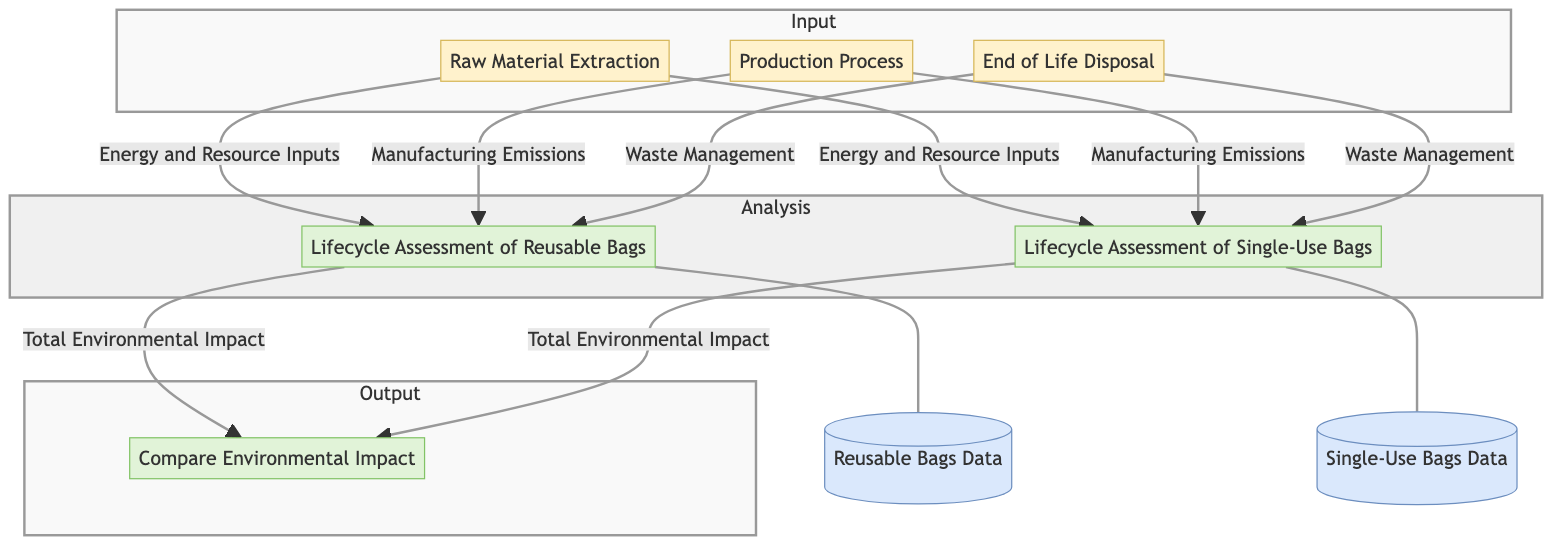What is one input entity for the reusable bags lifecycle assessment? The input entities for the lifecycle assessment of reusable bags include "Raw Material Extraction," "Production Process," and "End of Life Disposal." "Raw Material Extraction" is one of those input entities.
Answer: Raw Material Extraction How many processes are shown in the diagram? The diagram includes three distinct processes: "Lifecycle Assessment of Reusable Bags," "Lifecycle Assessment of Single-Use Bags," and "Compare Environmental Impact." Thus, the total number is three.
Answer: 3 What type of emissions are associated with the production process for both bag types? The production process contributes manufacturing emissions to the lifecycle assessments of both reusable and single-use bags, as indicated by the data flows connecting "Production Process" to each lifecycle assessment.
Answer: Manufacturing Emissions Which data store is linked to the lifecycle assessment of reusable bags? The "Reusable Bags Data" store is connected to the "Lifecycle Assessment of Reusable Bags" process, as shown by the dashed line that connects them in the diagram.
Answer: Reusable Bags Data What is the output from both lifecycle assessments to the comparison process? The output from both lifecycle assessments ("Lifecycle Assessment of Reusable Bags" and "Lifecycle Assessment of Single-Use Bags") to the comparison process is the "Total Environmental Impact." This is indicated by the labels on the arrows leading to "Compare Environmental Impact."
Answer: Total Environmental Impact What are the three input entities depicted in the diagram? The diagram shows three input entities: "Raw Material Extraction," "Production Process," and "End of Life Disposal." These entities are contained within the input subgraph of the diagram.
Answer: Raw Material Extraction, Production Process, End of Life Disposal Which process evaluates the environmental impact of single-use bags? The process that evaluates the environmental impact of single-use bags is labeled "Lifecycle Assessment of Single-Use Bags," distinctly identified within the diagram.
Answer: Lifecycle Assessment of Single-Use Bags What type of analysis is being conducted in the final output process? The final output process conducts a comparison analysis based on the environmental impact from both reusable and single-use bags, as indicated by "Compare Environmental Impact."
Answer: Comparison analysis 